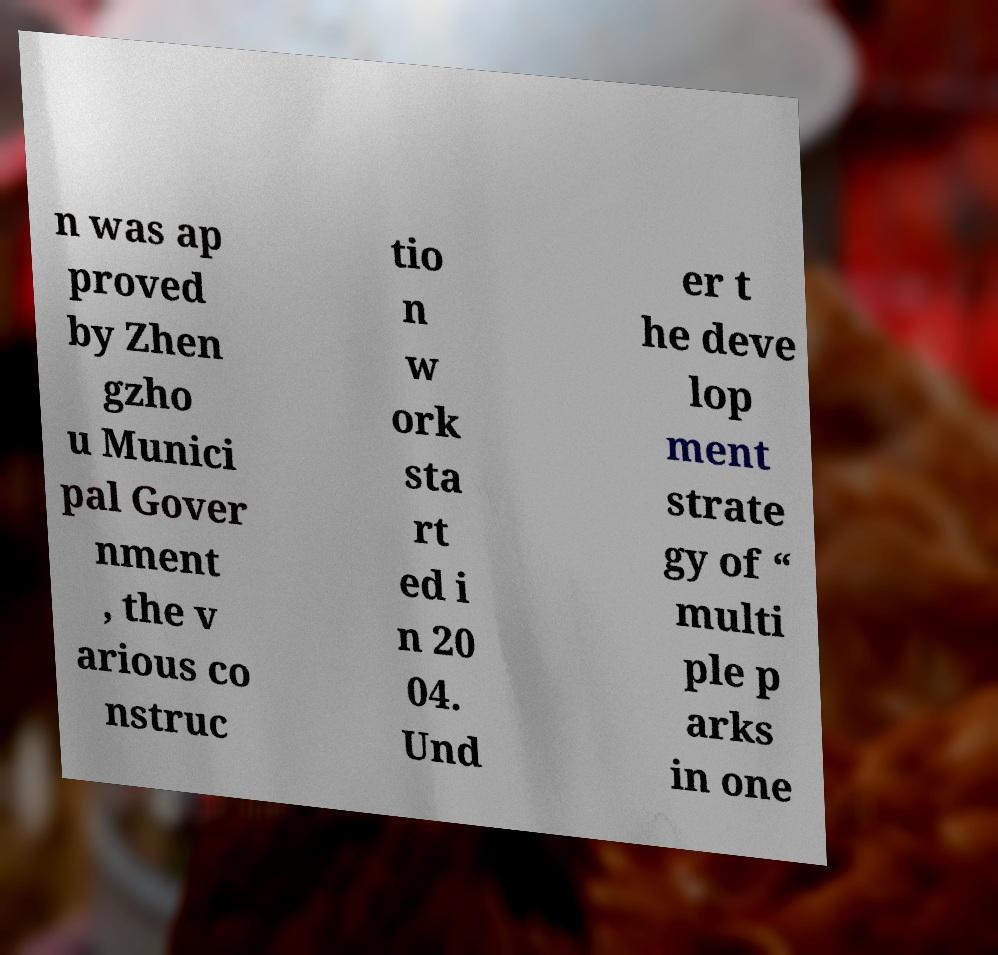Please identify and transcribe the text found in this image. n was ap proved by Zhen gzho u Munici pal Gover nment , the v arious co nstruc tio n w ork sta rt ed i n 20 04. Und er t he deve lop ment strate gy of “ multi ple p arks in one 